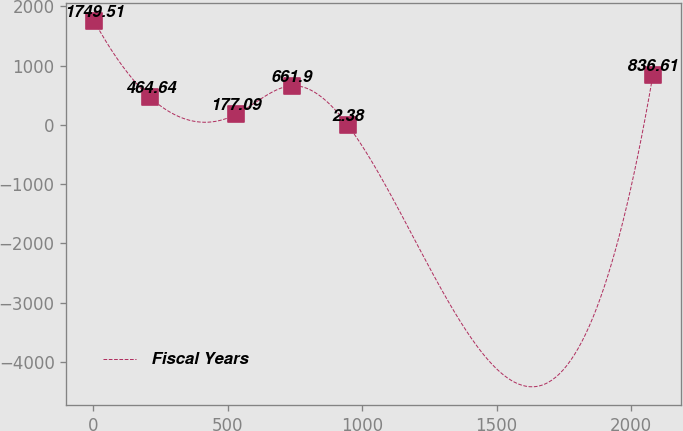Convert chart to OTSL. <chart><loc_0><loc_0><loc_500><loc_500><line_chart><ecel><fcel>Fiscal Years<nl><fcel>3.29<fcel>1749.51<nl><fcel>211.11<fcel>464.64<nl><fcel>529.78<fcel>177.09<nl><fcel>737.6<fcel>661.9<nl><fcel>945.42<fcel>2.38<nl><fcel>2081.48<fcel>836.61<nl></chart> 